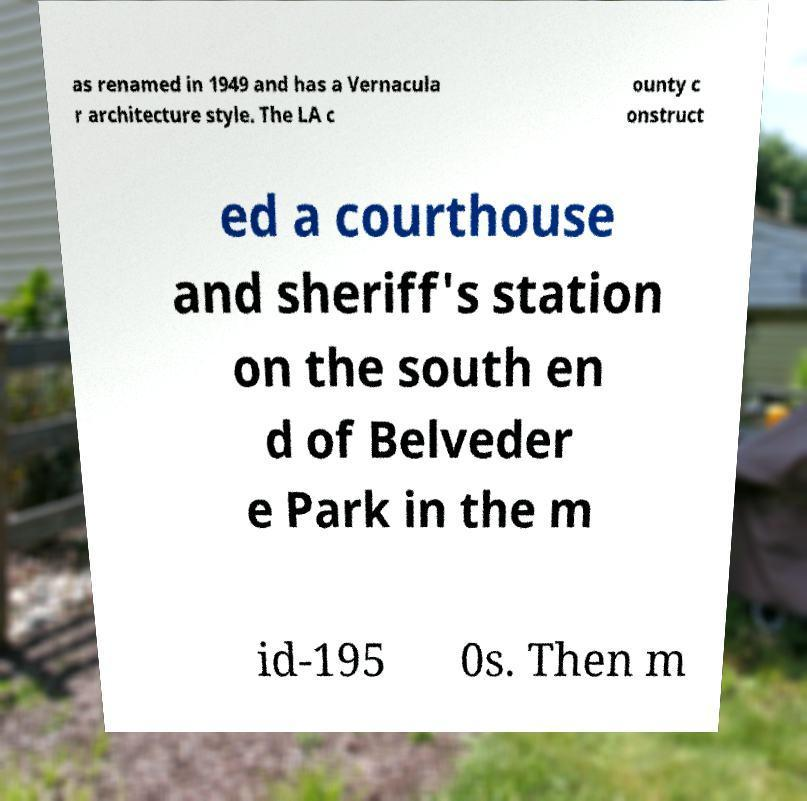There's text embedded in this image that I need extracted. Can you transcribe it verbatim? as renamed in 1949 and has a Vernacula r architecture style. The LA c ounty c onstruct ed a courthouse and sheriff's station on the south en d of Belveder e Park in the m id-195 0s. Then m 